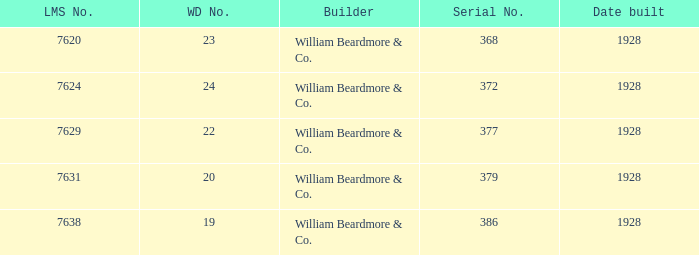Name the total number of wd number for lms number being 7638 1.0. 